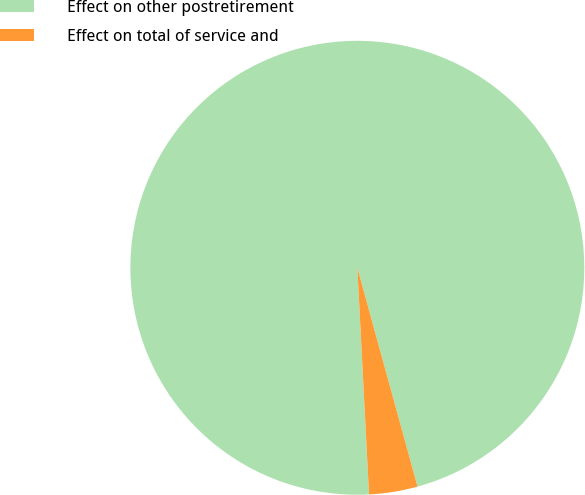<chart> <loc_0><loc_0><loc_500><loc_500><pie_chart><fcel>Effect on other postretirement<fcel>Effect on total of service and<nl><fcel>96.55%<fcel>3.45%<nl></chart> 